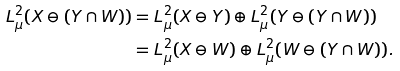Convert formula to latex. <formula><loc_0><loc_0><loc_500><loc_500>L ^ { 2 } _ { \mu } ( X \ominus ( Y \cap W ) ) & = L ^ { 2 } _ { \mu } ( X \ominus Y ) \oplus L ^ { 2 } _ { \mu } ( Y \ominus ( Y \cap W ) ) \\ & = L ^ { 2 } _ { \mu } ( X \ominus W ) \oplus L ^ { 2 } _ { \mu } ( W \ominus ( Y \cap W ) ) .</formula> 